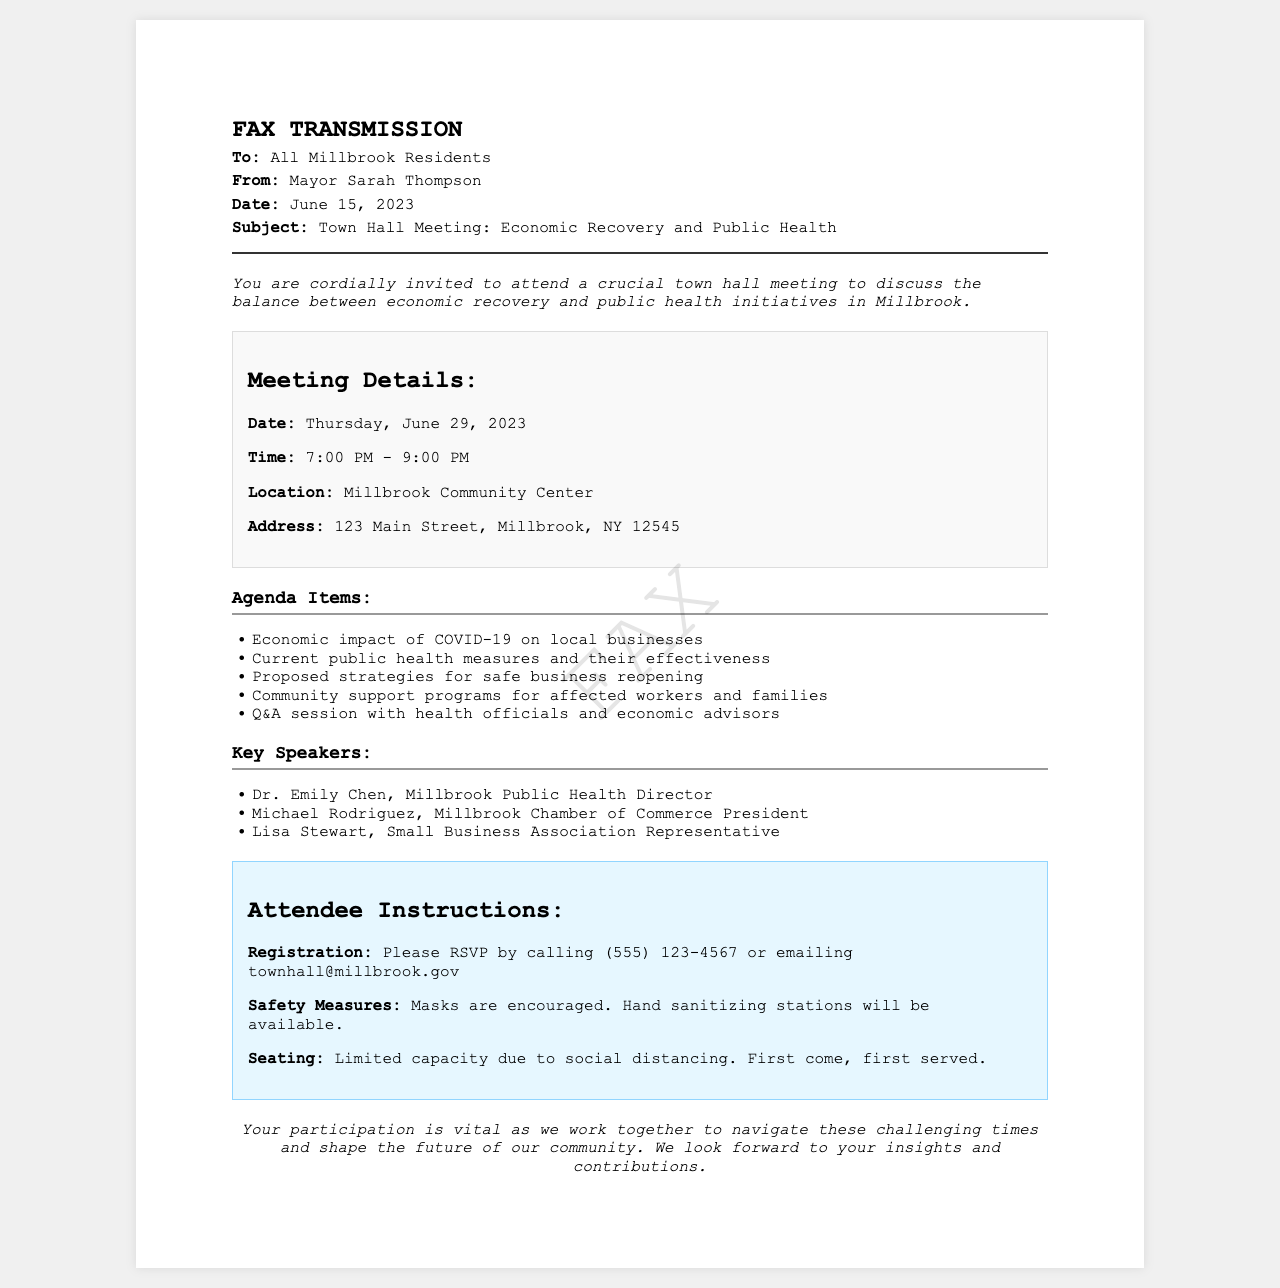What is the date of the town hall meeting? The date of the town hall meeting is explicitly stated in the document as Thursday, June 29, 2023.
Answer: Thursday, June 29, 2023 Who is the sender of the fax? The sender of the fax is listed in the document as Mayor Sarah Thompson.
Answer: Mayor Sarah Thompson What time does the meeting start? The start time of the meeting is provided in the document as 7:00 PM.
Answer: 7:00 PM What is one of the agenda items for the meeting? The document mentions multiple agenda items; one example stated is the economic impact of COVID-19 on local businesses.
Answer: Economic impact of COVID-19 on local businesses What are the safety measures mentioned for attendees? The document specifically mentions that masks are encouraged and hand sanitizing stations will be available.
Answer: Masks are encouraged What is the location of the meeting? The document clearly states that the meeting will take place at the Millbrook Community Center located at 123 Main Street, Millbrook, NY 12545.
Answer: Millbrook Community Center How can attendees register for the meeting? Attendees are instructed to RSVP by calling or emailing as mentioned in the document.
Answer: Calling (555) 123-4567 or emailing townhall@millbrook.gov Who is one of the key speakers? The document lists several key speakers, including Dr. Emily Chen, Millbrook Public Health Director.
Answer: Dr. Emily Chen What sort of capacity limitations are there for attendees? The document mentions that seating will be limited due to social distancing, indicating a first come, first served basis.
Answer: Limited capacity due to social distancing 